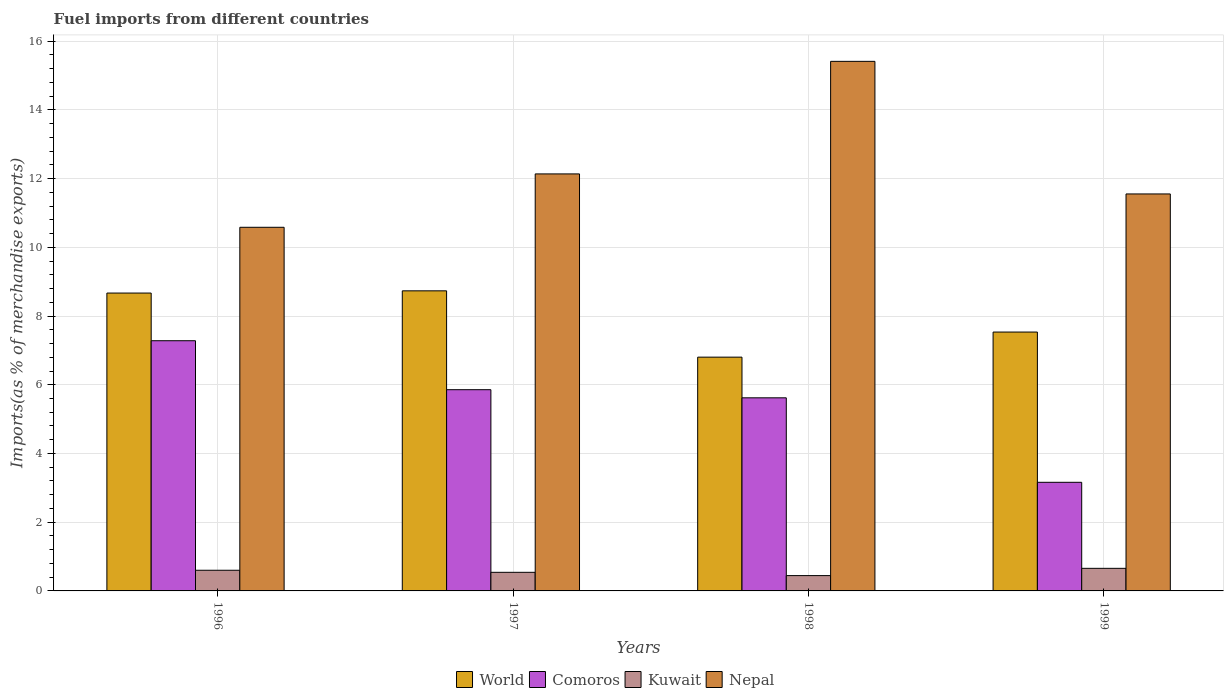How many different coloured bars are there?
Make the answer very short. 4. How many groups of bars are there?
Provide a short and direct response. 4. Are the number of bars per tick equal to the number of legend labels?
Make the answer very short. Yes. How many bars are there on the 4th tick from the left?
Make the answer very short. 4. What is the percentage of imports to different countries in World in 1997?
Your response must be concise. 8.73. Across all years, what is the maximum percentage of imports to different countries in Comoros?
Your response must be concise. 7.28. Across all years, what is the minimum percentage of imports to different countries in World?
Keep it short and to the point. 6.8. In which year was the percentage of imports to different countries in Nepal maximum?
Provide a succinct answer. 1998. What is the total percentage of imports to different countries in Nepal in the graph?
Your answer should be compact. 49.69. What is the difference between the percentage of imports to different countries in Comoros in 1996 and that in 1998?
Your response must be concise. 1.66. What is the difference between the percentage of imports to different countries in Kuwait in 1997 and the percentage of imports to different countries in Comoros in 1999?
Your answer should be very brief. -2.62. What is the average percentage of imports to different countries in Comoros per year?
Your answer should be very brief. 5.48. In the year 1999, what is the difference between the percentage of imports to different countries in World and percentage of imports to different countries in Nepal?
Ensure brevity in your answer.  -4.02. What is the ratio of the percentage of imports to different countries in World in 1996 to that in 1999?
Make the answer very short. 1.15. Is the percentage of imports to different countries in Comoros in 1998 less than that in 1999?
Keep it short and to the point. No. Is the difference between the percentage of imports to different countries in World in 1996 and 1999 greater than the difference between the percentage of imports to different countries in Nepal in 1996 and 1999?
Give a very brief answer. Yes. What is the difference between the highest and the second highest percentage of imports to different countries in Comoros?
Keep it short and to the point. 1.43. What is the difference between the highest and the lowest percentage of imports to different countries in Kuwait?
Make the answer very short. 0.21. In how many years, is the percentage of imports to different countries in Kuwait greater than the average percentage of imports to different countries in Kuwait taken over all years?
Offer a terse response. 2. Is it the case that in every year, the sum of the percentage of imports to different countries in Nepal and percentage of imports to different countries in Kuwait is greater than the sum of percentage of imports to different countries in World and percentage of imports to different countries in Comoros?
Your response must be concise. No. What does the 4th bar from the left in 1997 represents?
Provide a short and direct response. Nepal. Is it the case that in every year, the sum of the percentage of imports to different countries in Comoros and percentage of imports to different countries in Kuwait is greater than the percentage of imports to different countries in Nepal?
Your answer should be compact. No. How many bars are there?
Offer a very short reply. 16. Are all the bars in the graph horizontal?
Your answer should be compact. No. What is the difference between two consecutive major ticks on the Y-axis?
Offer a terse response. 2. Are the values on the major ticks of Y-axis written in scientific E-notation?
Provide a succinct answer. No. Does the graph contain any zero values?
Your answer should be very brief. No. Where does the legend appear in the graph?
Your answer should be very brief. Bottom center. How many legend labels are there?
Keep it short and to the point. 4. What is the title of the graph?
Give a very brief answer. Fuel imports from different countries. What is the label or title of the X-axis?
Make the answer very short. Years. What is the label or title of the Y-axis?
Ensure brevity in your answer.  Imports(as % of merchandise exports). What is the Imports(as % of merchandise exports) of World in 1996?
Provide a short and direct response. 8.67. What is the Imports(as % of merchandise exports) in Comoros in 1996?
Your answer should be very brief. 7.28. What is the Imports(as % of merchandise exports) in Kuwait in 1996?
Make the answer very short. 0.6. What is the Imports(as % of merchandise exports) of Nepal in 1996?
Your response must be concise. 10.58. What is the Imports(as % of merchandise exports) of World in 1997?
Offer a very short reply. 8.73. What is the Imports(as % of merchandise exports) of Comoros in 1997?
Provide a short and direct response. 5.86. What is the Imports(as % of merchandise exports) in Kuwait in 1997?
Provide a succinct answer. 0.54. What is the Imports(as % of merchandise exports) of Nepal in 1997?
Make the answer very short. 12.14. What is the Imports(as % of merchandise exports) in World in 1998?
Offer a very short reply. 6.8. What is the Imports(as % of merchandise exports) of Comoros in 1998?
Provide a short and direct response. 5.62. What is the Imports(as % of merchandise exports) in Kuwait in 1998?
Provide a succinct answer. 0.45. What is the Imports(as % of merchandise exports) in Nepal in 1998?
Ensure brevity in your answer.  15.41. What is the Imports(as % of merchandise exports) in World in 1999?
Provide a short and direct response. 7.53. What is the Imports(as % of merchandise exports) in Comoros in 1999?
Your response must be concise. 3.16. What is the Imports(as % of merchandise exports) of Kuwait in 1999?
Offer a terse response. 0.66. What is the Imports(as % of merchandise exports) in Nepal in 1999?
Ensure brevity in your answer.  11.55. Across all years, what is the maximum Imports(as % of merchandise exports) of World?
Provide a succinct answer. 8.73. Across all years, what is the maximum Imports(as % of merchandise exports) in Comoros?
Make the answer very short. 7.28. Across all years, what is the maximum Imports(as % of merchandise exports) of Kuwait?
Offer a terse response. 0.66. Across all years, what is the maximum Imports(as % of merchandise exports) in Nepal?
Your response must be concise. 15.41. Across all years, what is the minimum Imports(as % of merchandise exports) in World?
Your answer should be very brief. 6.8. Across all years, what is the minimum Imports(as % of merchandise exports) in Comoros?
Provide a succinct answer. 3.16. Across all years, what is the minimum Imports(as % of merchandise exports) of Kuwait?
Provide a succinct answer. 0.45. Across all years, what is the minimum Imports(as % of merchandise exports) of Nepal?
Your answer should be very brief. 10.58. What is the total Imports(as % of merchandise exports) in World in the graph?
Offer a very short reply. 31.74. What is the total Imports(as % of merchandise exports) in Comoros in the graph?
Provide a succinct answer. 21.92. What is the total Imports(as % of merchandise exports) in Kuwait in the graph?
Offer a very short reply. 2.25. What is the total Imports(as % of merchandise exports) in Nepal in the graph?
Ensure brevity in your answer.  49.69. What is the difference between the Imports(as % of merchandise exports) of World in 1996 and that in 1997?
Make the answer very short. -0.06. What is the difference between the Imports(as % of merchandise exports) in Comoros in 1996 and that in 1997?
Provide a short and direct response. 1.43. What is the difference between the Imports(as % of merchandise exports) of Kuwait in 1996 and that in 1997?
Your response must be concise. 0.06. What is the difference between the Imports(as % of merchandise exports) of Nepal in 1996 and that in 1997?
Ensure brevity in your answer.  -1.55. What is the difference between the Imports(as % of merchandise exports) of World in 1996 and that in 1998?
Make the answer very short. 1.87. What is the difference between the Imports(as % of merchandise exports) in Comoros in 1996 and that in 1998?
Give a very brief answer. 1.66. What is the difference between the Imports(as % of merchandise exports) in Kuwait in 1996 and that in 1998?
Offer a very short reply. 0.16. What is the difference between the Imports(as % of merchandise exports) in Nepal in 1996 and that in 1998?
Keep it short and to the point. -4.83. What is the difference between the Imports(as % of merchandise exports) in World in 1996 and that in 1999?
Offer a very short reply. 1.14. What is the difference between the Imports(as % of merchandise exports) of Comoros in 1996 and that in 1999?
Your answer should be very brief. 4.12. What is the difference between the Imports(as % of merchandise exports) of Kuwait in 1996 and that in 1999?
Provide a succinct answer. -0.06. What is the difference between the Imports(as % of merchandise exports) in Nepal in 1996 and that in 1999?
Offer a very short reply. -0.97. What is the difference between the Imports(as % of merchandise exports) of World in 1997 and that in 1998?
Your answer should be compact. 1.93. What is the difference between the Imports(as % of merchandise exports) in Comoros in 1997 and that in 1998?
Provide a short and direct response. 0.24. What is the difference between the Imports(as % of merchandise exports) in Kuwait in 1997 and that in 1998?
Your response must be concise. 0.1. What is the difference between the Imports(as % of merchandise exports) in Nepal in 1997 and that in 1998?
Provide a short and direct response. -3.28. What is the difference between the Imports(as % of merchandise exports) of World in 1997 and that in 1999?
Give a very brief answer. 1.2. What is the difference between the Imports(as % of merchandise exports) in Comoros in 1997 and that in 1999?
Give a very brief answer. 2.7. What is the difference between the Imports(as % of merchandise exports) of Kuwait in 1997 and that in 1999?
Provide a short and direct response. -0.12. What is the difference between the Imports(as % of merchandise exports) of Nepal in 1997 and that in 1999?
Make the answer very short. 0.58. What is the difference between the Imports(as % of merchandise exports) of World in 1998 and that in 1999?
Keep it short and to the point. -0.73. What is the difference between the Imports(as % of merchandise exports) of Comoros in 1998 and that in 1999?
Offer a terse response. 2.46. What is the difference between the Imports(as % of merchandise exports) of Kuwait in 1998 and that in 1999?
Offer a very short reply. -0.21. What is the difference between the Imports(as % of merchandise exports) of Nepal in 1998 and that in 1999?
Offer a terse response. 3.86. What is the difference between the Imports(as % of merchandise exports) of World in 1996 and the Imports(as % of merchandise exports) of Comoros in 1997?
Make the answer very short. 2.81. What is the difference between the Imports(as % of merchandise exports) of World in 1996 and the Imports(as % of merchandise exports) of Kuwait in 1997?
Provide a short and direct response. 8.13. What is the difference between the Imports(as % of merchandise exports) of World in 1996 and the Imports(as % of merchandise exports) of Nepal in 1997?
Your response must be concise. -3.47. What is the difference between the Imports(as % of merchandise exports) in Comoros in 1996 and the Imports(as % of merchandise exports) in Kuwait in 1997?
Provide a short and direct response. 6.74. What is the difference between the Imports(as % of merchandise exports) of Comoros in 1996 and the Imports(as % of merchandise exports) of Nepal in 1997?
Your answer should be compact. -4.86. What is the difference between the Imports(as % of merchandise exports) in Kuwait in 1996 and the Imports(as % of merchandise exports) in Nepal in 1997?
Provide a short and direct response. -11.54. What is the difference between the Imports(as % of merchandise exports) in World in 1996 and the Imports(as % of merchandise exports) in Comoros in 1998?
Make the answer very short. 3.05. What is the difference between the Imports(as % of merchandise exports) in World in 1996 and the Imports(as % of merchandise exports) in Kuwait in 1998?
Your answer should be compact. 8.22. What is the difference between the Imports(as % of merchandise exports) of World in 1996 and the Imports(as % of merchandise exports) of Nepal in 1998?
Provide a succinct answer. -6.74. What is the difference between the Imports(as % of merchandise exports) of Comoros in 1996 and the Imports(as % of merchandise exports) of Kuwait in 1998?
Your answer should be compact. 6.84. What is the difference between the Imports(as % of merchandise exports) of Comoros in 1996 and the Imports(as % of merchandise exports) of Nepal in 1998?
Your response must be concise. -8.13. What is the difference between the Imports(as % of merchandise exports) in Kuwait in 1996 and the Imports(as % of merchandise exports) in Nepal in 1998?
Give a very brief answer. -14.81. What is the difference between the Imports(as % of merchandise exports) in World in 1996 and the Imports(as % of merchandise exports) in Comoros in 1999?
Keep it short and to the point. 5.51. What is the difference between the Imports(as % of merchandise exports) of World in 1996 and the Imports(as % of merchandise exports) of Kuwait in 1999?
Give a very brief answer. 8.01. What is the difference between the Imports(as % of merchandise exports) in World in 1996 and the Imports(as % of merchandise exports) in Nepal in 1999?
Your answer should be very brief. -2.88. What is the difference between the Imports(as % of merchandise exports) of Comoros in 1996 and the Imports(as % of merchandise exports) of Kuwait in 1999?
Your answer should be compact. 6.62. What is the difference between the Imports(as % of merchandise exports) in Comoros in 1996 and the Imports(as % of merchandise exports) in Nepal in 1999?
Offer a very short reply. -4.27. What is the difference between the Imports(as % of merchandise exports) in Kuwait in 1996 and the Imports(as % of merchandise exports) in Nepal in 1999?
Your response must be concise. -10.95. What is the difference between the Imports(as % of merchandise exports) of World in 1997 and the Imports(as % of merchandise exports) of Comoros in 1998?
Ensure brevity in your answer.  3.11. What is the difference between the Imports(as % of merchandise exports) of World in 1997 and the Imports(as % of merchandise exports) of Kuwait in 1998?
Offer a very short reply. 8.29. What is the difference between the Imports(as % of merchandise exports) of World in 1997 and the Imports(as % of merchandise exports) of Nepal in 1998?
Make the answer very short. -6.68. What is the difference between the Imports(as % of merchandise exports) of Comoros in 1997 and the Imports(as % of merchandise exports) of Kuwait in 1998?
Offer a terse response. 5.41. What is the difference between the Imports(as % of merchandise exports) of Comoros in 1997 and the Imports(as % of merchandise exports) of Nepal in 1998?
Give a very brief answer. -9.56. What is the difference between the Imports(as % of merchandise exports) in Kuwait in 1997 and the Imports(as % of merchandise exports) in Nepal in 1998?
Keep it short and to the point. -14.87. What is the difference between the Imports(as % of merchandise exports) of World in 1997 and the Imports(as % of merchandise exports) of Comoros in 1999?
Keep it short and to the point. 5.57. What is the difference between the Imports(as % of merchandise exports) of World in 1997 and the Imports(as % of merchandise exports) of Kuwait in 1999?
Your answer should be very brief. 8.08. What is the difference between the Imports(as % of merchandise exports) in World in 1997 and the Imports(as % of merchandise exports) in Nepal in 1999?
Your response must be concise. -2.82. What is the difference between the Imports(as % of merchandise exports) in Comoros in 1997 and the Imports(as % of merchandise exports) in Kuwait in 1999?
Ensure brevity in your answer.  5.2. What is the difference between the Imports(as % of merchandise exports) in Comoros in 1997 and the Imports(as % of merchandise exports) in Nepal in 1999?
Your response must be concise. -5.7. What is the difference between the Imports(as % of merchandise exports) of Kuwait in 1997 and the Imports(as % of merchandise exports) of Nepal in 1999?
Provide a succinct answer. -11.01. What is the difference between the Imports(as % of merchandise exports) of World in 1998 and the Imports(as % of merchandise exports) of Comoros in 1999?
Offer a very short reply. 3.64. What is the difference between the Imports(as % of merchandise exports) of World in 1998 and the Imports(as % of merchandise exports) of Kuwait in 1999?
Offer a very short reply. 6.15. What is the difference between the Imports(as % of merchandise exports) of World in 1998 and the Imports(as % of merchandise exports) of Nepal in 1999?
Your answer should be very brief. -4.75. What is the difference between the Imports(as % of merchandise exports) in Comoros in 1998 and the Imports(as % of merchandise exports) in Kuwait in 1999?
Offer a very short reply. 4.96. What is the difference between the Imports(as % of merchandise exports) in Comoros in 1998 and the Imports(as % of merchandise exports) in Nepal in 1999?
Offer a very short reply. -5.93. What is the difference between the Imports(as % of merchandise exports) of Kuwait in 1998 and the Imports(as % of merchandise exports) of Nepal in 1999?
Make the answer very short. -11.11. What is the average Imports(as % of merchandise exports) of World per year?
Your answer should be very brief. 7.94. What is the average Imports(as % of merchandise exports) of Comoros per year?
Offer a terse response. 5.48. What is the average Imports(as % of merchandise exports) in Kuwait per year?
Your answer should be compact. 0.56. What is the average Imports(as % of merchandise exports) in Nepal per year?
Keep it short and to the point. 12.42. In the year 1996, what is the difference between the Imports(as % of merchandise exports) in World and Imports(as % of merchandise exports) in Comoros?
Give a very brief answer. 1.39. In the year 1996, what is the difference between the Imports(as % of merchandise exports) in World and Imports(as % of merchandise exports) in Kuwait?
Keep it short and to the point. 8.07. In the year 1996, what is the difference between the Imports(as % of merchandise exports) in World and Imports(as % of merchandise exports) in Nepal?
Make the answer very short. -1.91. In the year 1996, what is the difference between the Imports(as % of merchandise exports) in Comoros and Imports(as % of merchandise exports) in Kuwait?
Provide a short and direct response. 6.68. In the year 1996, what is the difference between the Imports(as % of merchandise exports) of Comoros and Imports(as % of merchandise exports) of Nepal?
Give a very brief answer. -3.3. In the year 1996, what is the difference between the Imports(as % of merchandise exports) of Kuwait and Imports(as % of merchandise exports) of Nepal?
Provide a succinct answer. -9.98. In the year 1997, what is the difference between the Imports(as % of merchandise exports) of World and Imports(as % of merchandise exports) of Comoros?
Offer a very short reply. 2.88. In the year 1997, what is the difference between the Imports(as % of merchandise exports) in World and Imports(as % of merchandise exports) in Kuwait?
Make the answer very short. 8.19. In the year 1997, what is the difference between the Imports(as % of merchandise exports) of World and Imports(as % of merchandise exports) of Nepal?
Provide a short and direct response. -3.4. In the year 1997, what is the difference between the Imports(as % of merchandise exports) in Comoros and Imports(as % of merchandise exports) in Kuwait?
Offer a very short reply. 5.32. In the year 1997, what is the difference between the Imports(as % of merchandise exports) in Comoros and Imports(as % of merchandise exports) in Nepal?
Offer a terse response. -6.28. In the year 1997, what is the difference between the Imports(as % of merchandise exports) in Kuwait and Imports(as % of merchandise exports) in Nepal?
Provide a short and direct response. -11.6. In the year 1998, what is the difference between the Imports(as % of merchandise exports) in World and Imports(as % of merchandise exports) in Comoros?
Offer a very short reply. 1.18. In the year 1998, what is the difference between the Imports(as % of merchandise exports) in World and Imports(as % of merchandise exports) in Kuwait?
Provide a short and direct response. 6.36. In the year 1998, what is the difference between the Imports(as % of merchandise exports) of World and Imports(as % of merchandise exports) of Nepal?
Offer a very short reply. -8.61. In the year 1998, what is the difference between the Imports(as % of merchandise exports) in Comoros and Imports(as % of merchandise exports) in Kuwait?
Your answer should be very brief. 5.17. In the year 1998, what is the difference between the Imports(as % of merchandise exports) of Comoros and Imports(as % of merchandise exports) of Nepal?
Provide a succinct answer. -9.79. In the year 1998, what is the difference between the Imports(as % of merchandise exports) of Kuwait and Imports(as % of merchandise exports) of Nepal?
Offer a very short reply. -14.97. In the year 1999, what is the difference between the Imports(as % of merchandise exports) of World and Imports(as % of merchandise exports) of Comoros?
Make the answer very short. 4.37. In the year 1999, what is the difference between the Imports(as % of merchandise exports) in World and Imports(as % of merchandise exports) in Kuwait?
Offer a very short reply. 6.88. In the year 1999, what is the difference between the Imports(as % of merchandise exports) of World and Imports(as % of merchandise exports) of Nepal?
Your response must be concise. -4.02. In the year 1999, what is the difference between the Imports(as % of merchandise exports) in Comoros and Imports(as % of merchandise exports) in Kuwait?
Keep it short and to the point. 2.5. In the year 1999, what is the difference between the Imports(as % of merchandise exports) of Comoros and Imports(as % of merchandise exports) of Nepal?
Make the answer very short. -8.39. In the year 1999, what is the difference between the Imports(as % of merchandise exports) of Kuwait and Imports(as % of merchandise exports) of Nepal?
Offer a terse response. -10.9. What is the ratio of the Imports(as % of merchandise exports) in Comoros in 1996 to that in 1997?
Provide a succinct answer. 1.24. What is the ratio of the Imports(as % of merchandise exports) of Kuwait in 1996 to that in 1997?
Make the answer very short. 1.11. What is the ratio of the Imports(as % of merchandise exports) of Nepal in 1996 to that in 1997?
Provide a succinct answer. 0.87. What is the ratio of the Imports(as % of merchandise exports) in World in 1996 to that in 1998?
Your response must be concise. 1.27. What is the ratio of the Imports(as % of merchandise exports) in Comoros in 1996 to that in 1998?
Your response must be concise. 1.3. What is the ratio of the Imports(as % of merchandise exports) in Kuwait in 1996 to that in 1998?
Ensure brevity in your answer.  1.35. What is the ratio of the Imports(as % of merchandise exports) of Nepal in 1996 to that in 1998?
Offer a terse response. 0.69. What is the ratio of the Imports(as % of merchandise exports) in World in 1996 to that in 1999?
Your response must be concise. 1.15. What is the ratio of the Imports(as % of merchandise exports) in Comoros in 1996 to that in 1999?
Keep it short and to the point. 2.3. What is the ratio of the Imports(as % of merchandise exports) in Kuwait in 1996 to that in 1999?
Your response must be concise. 0.91. What is the ratio of the Imports(as % of merchandise exports) in Nepal in 1996 to that in 1999?
Provide a succinct answer. 0.92. What is the ratio of the Imports(as % of merchandise exports) of World in 1997 to that in 1998?
Ensure brevity in your answer.  1.28. What is the ratio of the Imports(as % of merchandise exports) of Comoros in 1997 to that in 1998?
Offer a terse response. 1.04. What is the ratio of the Imports(as % of merchandise exports) of Kuwait in 1997 to that in 1998?
Ensure brevity in your answer.  1.21. What is the ratio of the Imports(as % of merchandise exports) of Nepal in 1997 to that in 1998?
Your answer should be very brief. 0.79. What is the ratio of the Imports(as % of merchandise exports) in World in 1997 to that in 1999?
Provide a short and direct response. 1.16. What is the ratio of the Imports(as % of merchandise exports) of Comoros in 1997 to that in 1999?
Ensure brevity in your answer.  1.85. What is the ratio of the Imports(as % of merchandise exports) of Kuwait in 1997 to that in 1999?
Give a very brief answer. 0.82. What is the ratio of the Imports(as % of merchandise exports) of Nepal in 1997 to that in 1999?
Make the answer very short. 1.05. What is the ratio of the Imports(as % of merchandise exports) in World in 1998 to that in 1999?
Give a very brief answer. 0.9. What is the ratio of the Imports(as % of merchandise exports) in Comoros in 1998 to that in 1999?
Ensure brevity in your answer.  1.78. What is the ratio of the Imports(as % of merchandise exports) of Kuwait in 1998 to that in 1999?
Offer a terse response. 0.68. What is the ratio of the Imports(as % of merchandise exports) in Nepal in 1998 to that in 1999?
Make the answer very short. 1.33. What is the difference between the highest and the second highest Imports(as % of merchandise exports) in World?
Offer a terse response. 0.06. What is the difference between the highest and the second highest Imports(as % of merchandise exports) of Comoros?
Your answer should be very brief. 1.43. What is the difference between the highest and the second highest Imports(as % of merchandise exports) in Kuwait?
Keep it short and to the point. 0.06. What is the difference between the highest and the second highest Imports(as % of merchandise exports) in Nepal?
Give a very brief answer. 3.28. What is the difference between the highest and the lowest Imports(as % of merchandise exports) of World?
Offer a terse response. 1.93. What is the difference between the highest and the lowest Imports(as % of merchandise exports) of Comoros?
Your answer should be very brief. 4.12. What is the difference between the highest and the lowest Imports(as % of merchandise exports) of Kuwait?
Ensure brevity in your answer.  0.21. What is the difference between the highest and the lowest Imports(as % of merchandise exports) of Nepal?
Your answer should be compact. 4.83. 